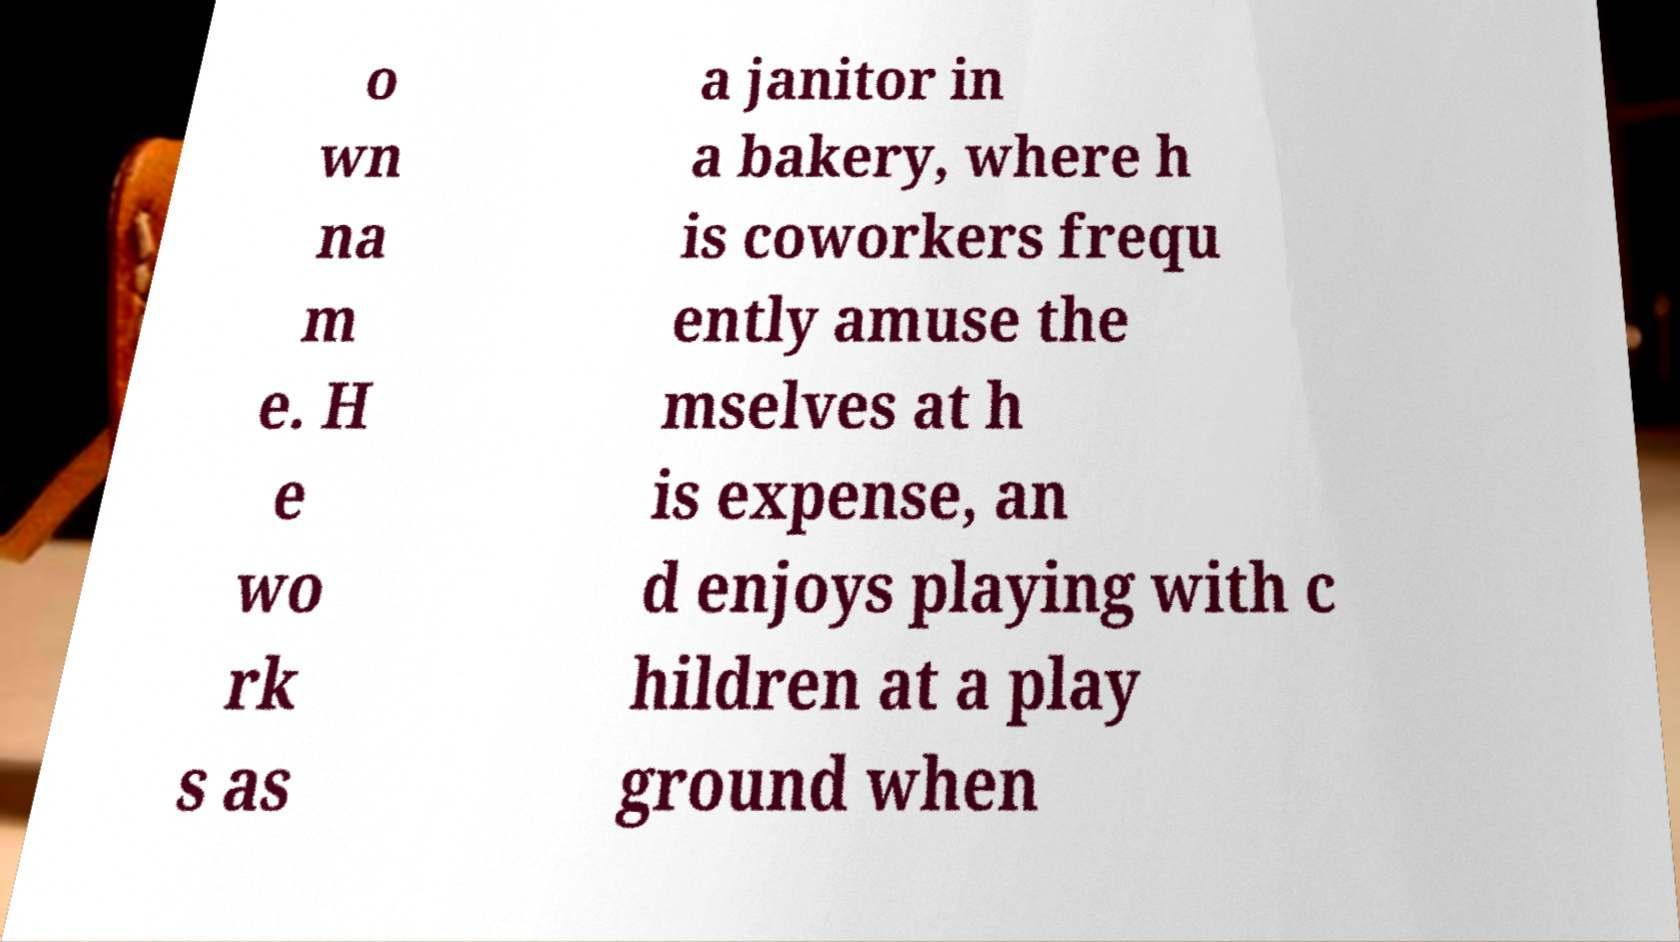Could you extract and type out the text from this image? o wn na m e. H e wo rk s as a janitor in a bakery, where h is coworkers frequ ently amuse the mselves at h is expense, an d enjoys playing with c hildren at a play ground when 